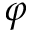Convert formula to latex. <formula><loc_0><loc_0><loc_500><loc_500>\varphi</formula> 